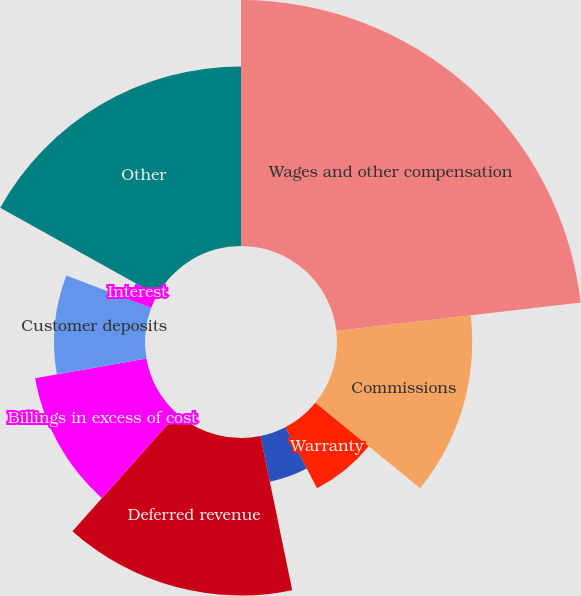<chart> <loc_0><loc_0><loc_500><loc_500><pie_chart><fcel>Wages and other compensation<fcel>Commissions<fcel>Warranty<fcel>Accrued dividend<fcel>Deferred revenue<fcel>Billings in excess of cost<fcel>Customer deposits<fcel>Interest<fcel>Other<nl><fcel>23.16%<fcel>12.73%<fcel>6.48%<fcel>4.39%<fcel>14.82%<fcel>10.65%<fcel>8.56%<fcel>2.3%<fcel>16.91%<nl></chart> 